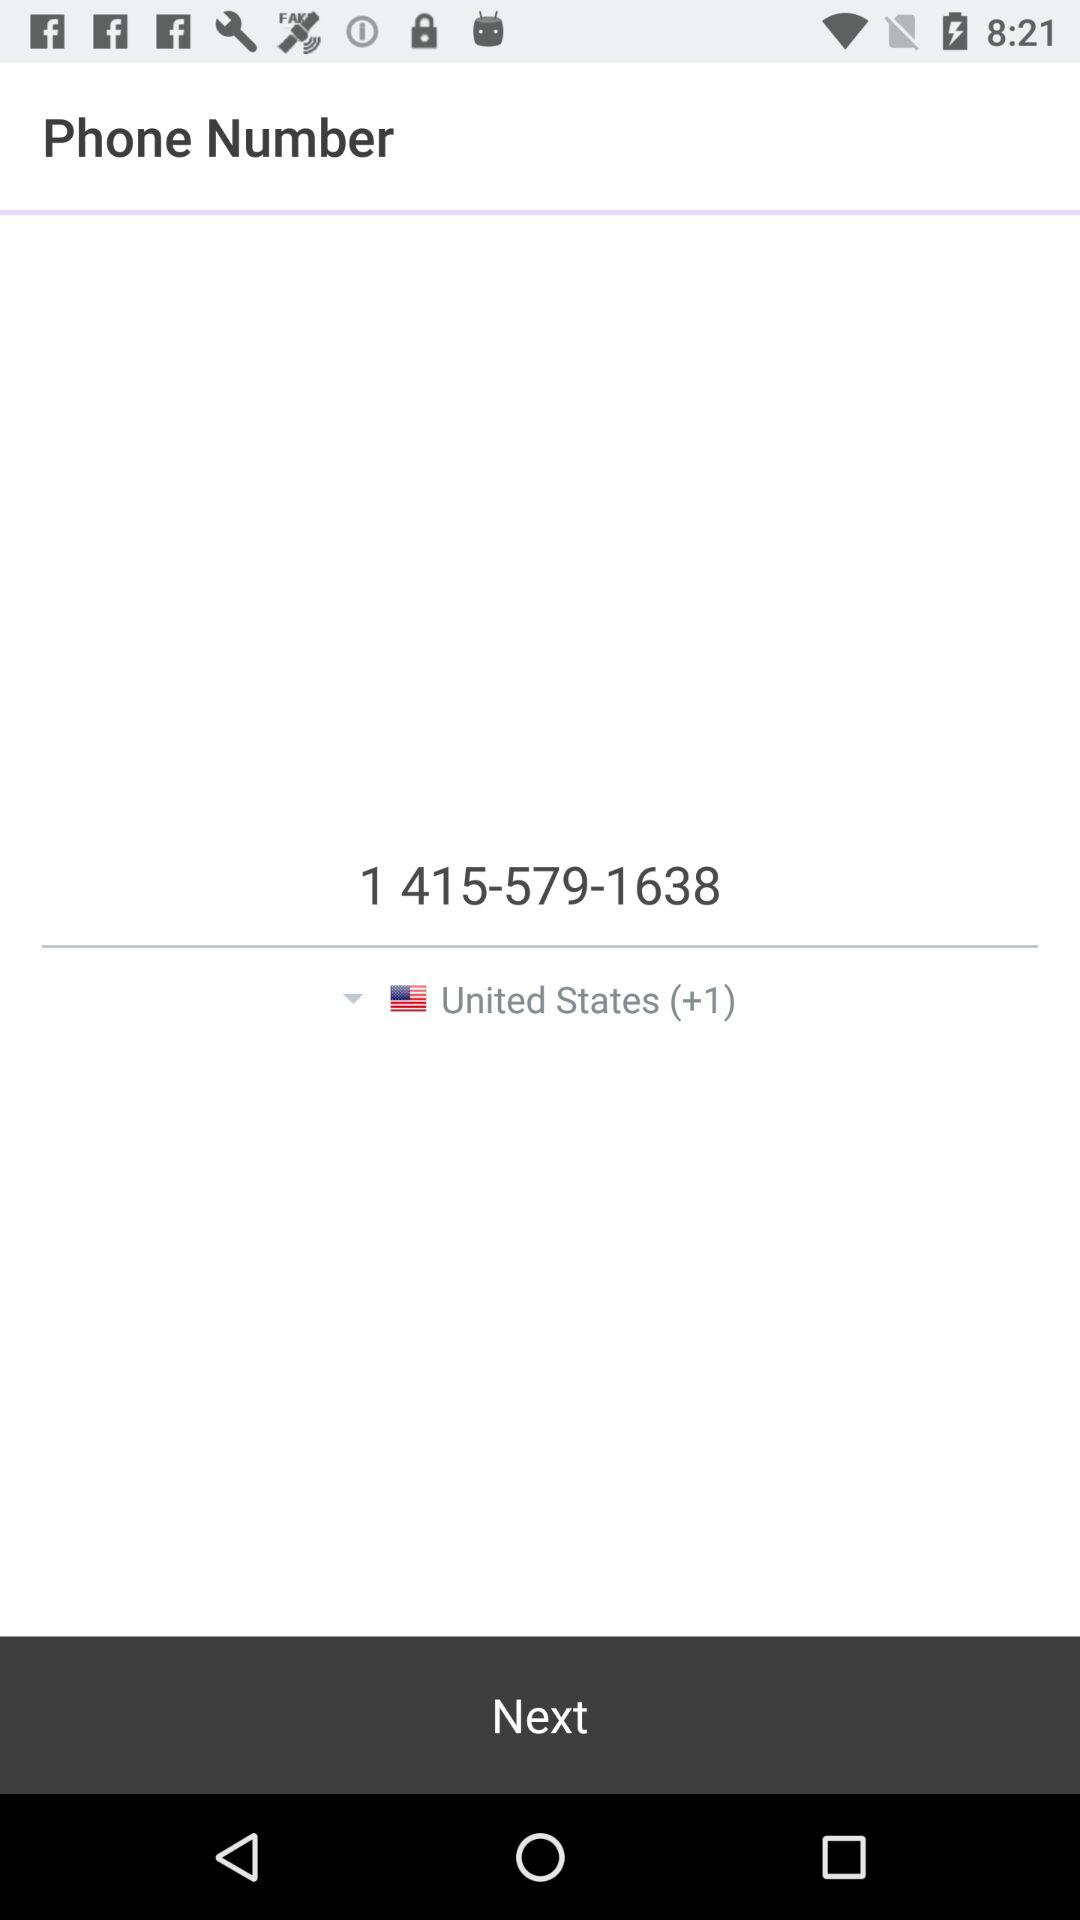What is the name of the country? The name of the country is the United States. 